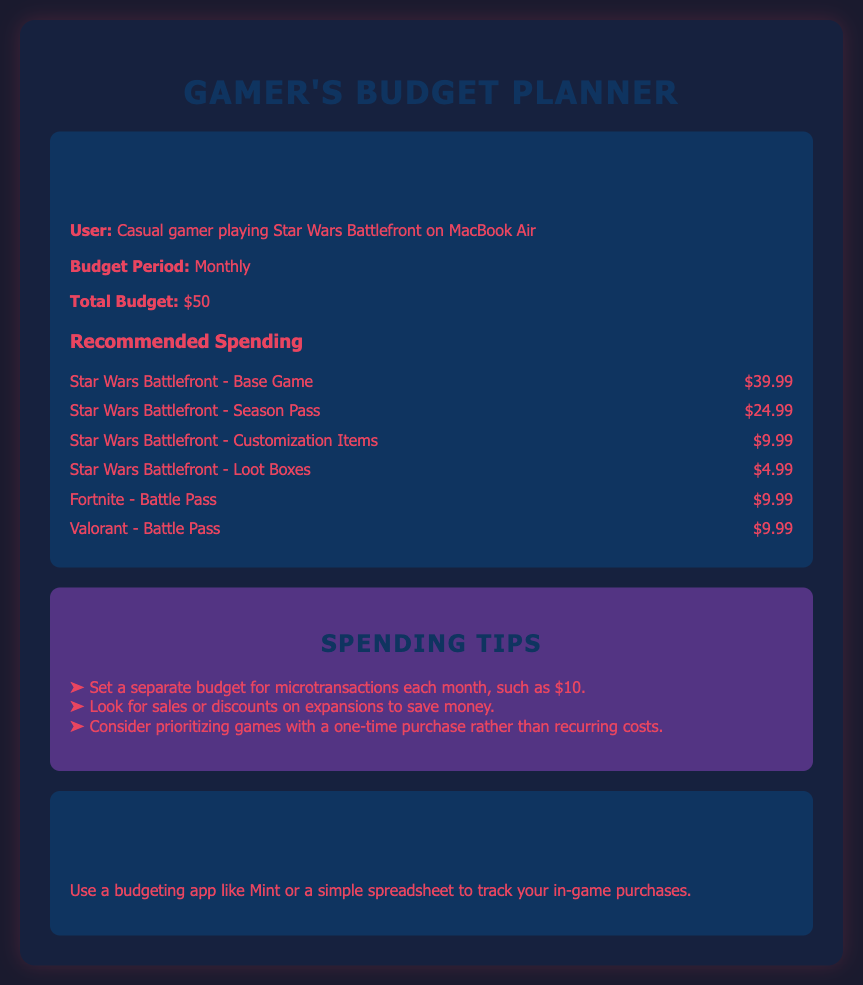what is the total budget? The total budget specified in the document is $50.
Answer: $50 what is the price of the Star Wars Battlefront - Base Game? The document states that the price of the Star Wars Battlefront - Base Game is $39.99.
Answer: $39.99 how much is the Season Pass for Star Wars Battlefront? The document lists the Star Wars Battlefront - Season Pass price as $24.99.
Answer: $24.99 how much can a budget for microtransactions be set at each month? The spending tips suggest setting a separate budget for microtransactions, such as $10.
Answer: $10 which game has a Battle Pass priced at $9.99? The document mentions Fortnite - Battle Pass, which is priced at $9.99.
Answer: Fortnite - Battle Pass what percentage of the total budget does the Star Wars Battlefront - Base Game take up? The Star Wars Battlefront - Base Game costs $39.99 out of a $50 budget, equating to approximately 80%.
Answer: 80% how many recommended spending items are listed in the document? The document lists a total of six recommended spending items.
Answer: 6 what is one of the apps suggested for tracking spending? The document suggests using Mint as a budgeting app to track in-game purchases.
Answer: Mint 